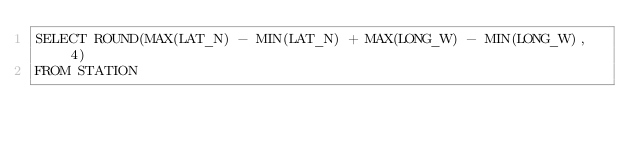<code> <loc_0><loc_0><loc_500><loc_500><_SQL_>SELECT ROUND(MAX(LAT_N) - MIN(LAT_N) + MAX(LONG_W) - MIN(LONG_W), 4)
FROM STATION</code> 